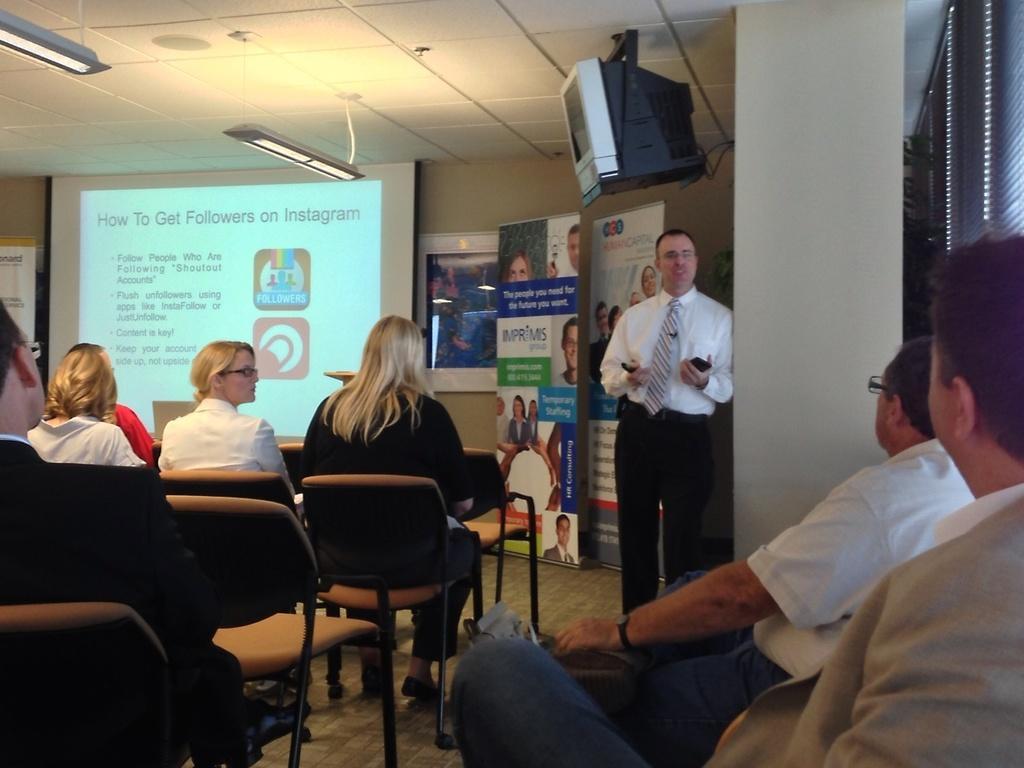Can you describe this image briefly? In this image, in the middle a man is speaking something ,he wear a white shirt ,tie ,trouser. On the right there are two man they are sitting on the chair. In the middle there are many people sitting on the chairs. In the back ground there is a poster ,projector screen and some text. In the top there is a television ,light and roof. 